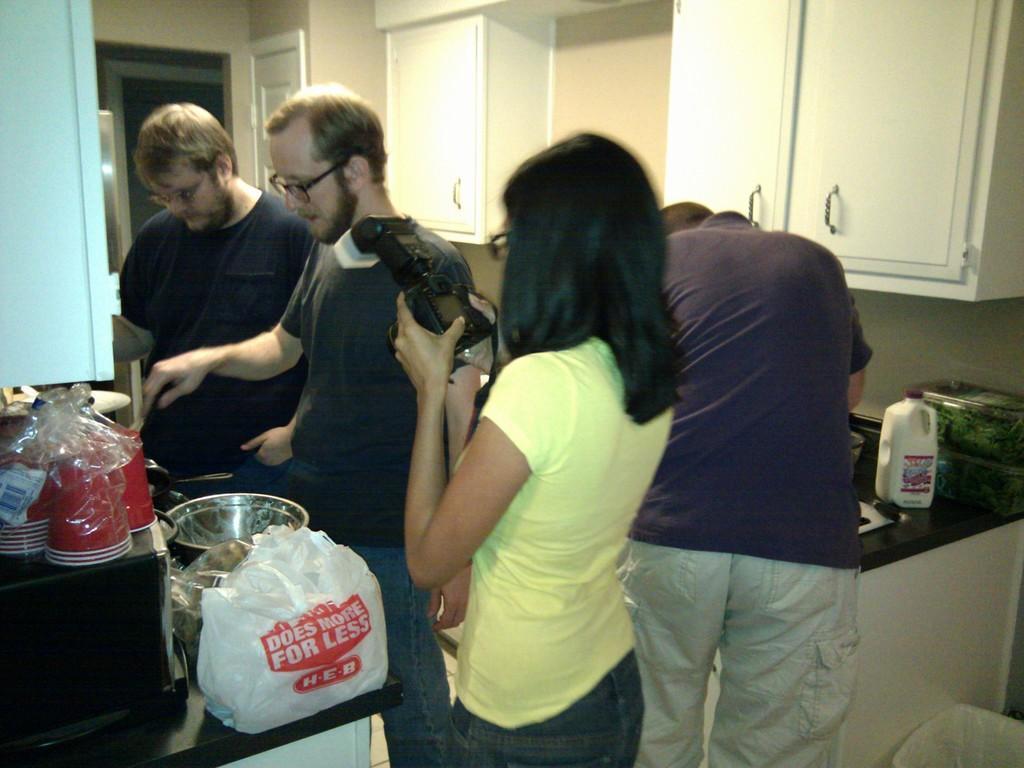In one or two sentences, can you explain what this image depicts? In the center of the image there are group of persons standing on the floor. On the right side of the image we can see a person standing at the countertop. On the left side of the image we can see two men cooking. On the countertop we can see glasses, cover vessels. In the background there are cupboards, door and wall. 